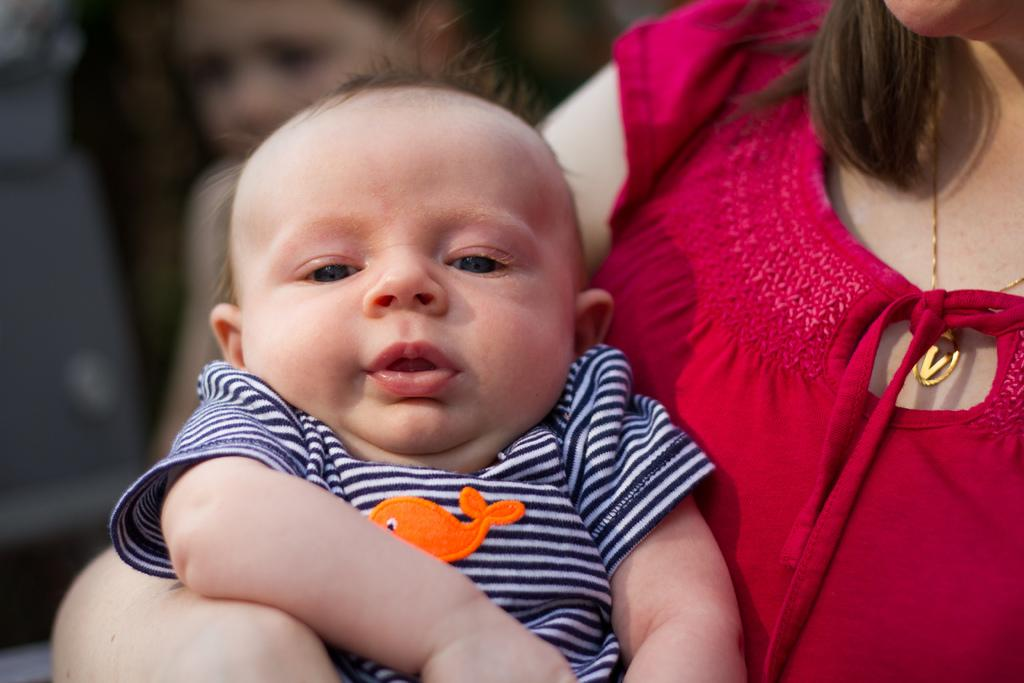Who is the main subject in the image? There is a woman in the image. What is the woman wearing? The woman is wearing a red dress. What is the woman holding in the image? The woman is holding a baby. Can you describe the other person in the image? There is another person in the background of the image. What flavor of popcorn can be seen in the image? There is no popcorn present in the image. 